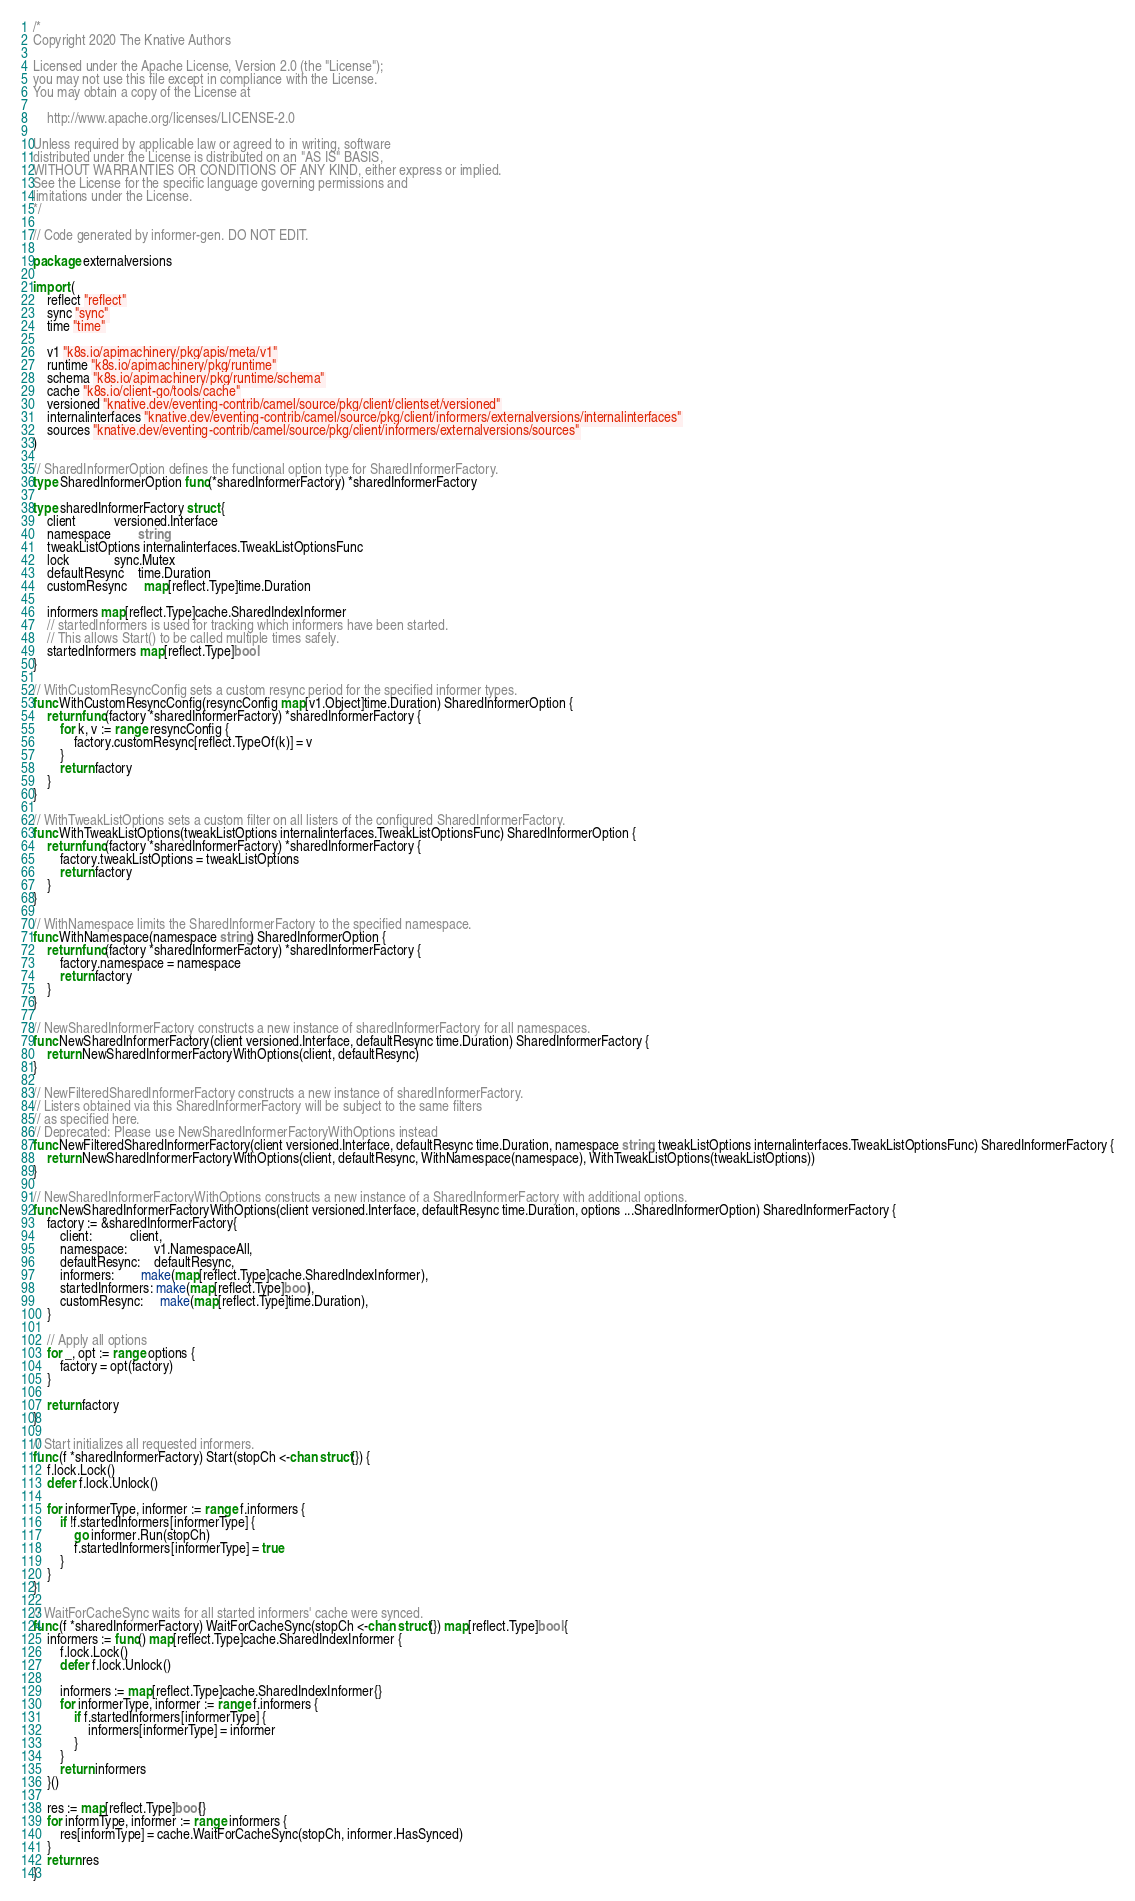Convert code to text. <code><loc_0><loc_0><loc_500><loc_500><_Go_>/*
Copyright 2020 The Knative Authors

Licensed under the Apache License, Version 2.0 (the "License");
you may not use this file except in compliance with the License.
You may obtain a copy of the License at

    http://www.apache.org/licenses/LICENSE-2.0

Unless required by applicable law or agreed to in writing, software
distributed under the License is distributed on an "AS IS" BASIS,
WITHOUT WARRANTIES OR CONDITIONS OF ANY KIND, either express or implied.
See the License for the specific language governing permissions and
limitations under the License.
*/

// Code generated by informer-gen. DO NOT EDIT.

package externalversions

import (
	reflect "reflect"
	sync "sync"
	time "time"

	v1 "k8s.io/apimachinery/pkg/apis/meta/v1"
	runtime "k8s.io/apimachinery/pkg/runtime"
	schema "k8s.io/apimachinery/pkg/runtime/schema"
	cache "k8s.io/client-go/tools/cache"
	versioned "knative.dev/eventing-contrib/camel/source/pkg/client/clientset/versioned"
	internalinterfaces "knative.dev/eventing-contrib/camel/source/pkg/client/informers/externalversions/internalinterfaces"
	sources "knative.dev/eventing-contrib/camel/source/pkg/client/informers/externalversions/sources"
)

// SharedInformerOption defines the functional option type for SharedInformerFactory.
type SharedInformerOption func(*sharedInformerFactory) *sharedInformerFactory

type sharedInformerFactory struct {
	client           versioned.Interface
	namespace        string
	tweakListOptions internalinterfaces.TweakListOptionsFunc
	lock             sync.Mutex
	defaultResync    time.Duration
	customResync     map[reflect.Type]time.Duration

	informers map[reflect.Type]cache.SharedIndexInformer
	// startedInformers is used for tracking which informers have been started.
	// This allows Start() to be called multiple times safely.
	startedInformers map[reflect.Type]bool
}

// WithCustomResyncConfig sets a custom resync period for the specified informer types.
func WithCustomResyncConfig(resyncConfig map[v1.Object]time.Duration) SharedInformerOption {
	return func(factory *sharedInformerFactory) *sharedInformerFactory {
		for k, v := range resyncConfig {
			factory.customResync[reflect.TypeOf(k)] = v
		}
		return factory
	}
}

// WithTweakListOptions sets a custom filter on all listers of the configured SharedInformerFactory.
func WithTweakListOptions(tweakListOptions internalinterfaces.TweakListOptionsFunc) SharedInformerOption {
	return func(factory *sharedInformerFactory) *sharedInformerFactory {
		factory.tweakListOptions = tweakListOptions
		return factory
	}
}

// WithNamespace limits the SharedInformerFactory to the specified namespace.
func WithNamespace(namespace string) SharedInformerOption {
	return func(factory *sharedInformerFactory) *sharedInformerFactory {
		factory.namespace = namespace
		return factory
	}
}

// NewSharedInformerFactory constructs a new instance of sharedInformerFactory for all namespaces.
func NewSharedInformerFactory(client versioned.Interface, defaultResync time.Duration) SharedInformerFactory {
	return NewSharedInformerFactoryWithOptions(client, defaultResync)
}

// NewFilteredSharedInformerFactory constructs a new instance of sharedInformerFactory.
// Listers obtained via this SharedInformerFactory will be subject to the same filters
// as specified here.
// Deprecated: Please use NewSharedInformerFactoryWithOptions instead
func NewFilteredSharedInformerFactory(client versioned.Interface, defaultResync time.Duration, namespace string, tweakListOptions internalinterfaces.TweakListOptionsFunc) SharedInformerFactory {
	return NewSharedInformerFactoryWithOptions(client, defaultResync, WithNamespace(namespace), WithTweakListOptions(tweakListOptions))
}

// NewSharedInformerFactoryWithOptions constructs a new instance of a SharedInformerFactory with additional options.
func NewSharedInformerFactoryWithOptions(client versioned.Interface, defaultResync time.Duration, options ...SharedInformerOption) SharedInformerFactory {
	factory := &sharedInformerFactory{
		client:           client,
		namespace:        v1.NamespaceAll,
		defaultResync:    defaultResync,
		informers:        make(map[reflect.Type]cache.SharedIndexInformer),
		startedInformers: make(map[reflect.Type]bool),
		customResync:     make(map[reflect.Type]time.Duration),
	}

	// Apply all options
	for _, opt := range options {
		factory = opt(factory)
	}

	return factory
}

// Start initializes all requested informers.
func (f *sharedInformerFactory) Start(stopCh <-chan struct{}) {
	f.lock.Lock()
	defer f.lock.Unlock()

	for informerType, informer := range f.informers {
		if !f.startedInformers[informerType] {
			go informer.Run(stopCh)
			f.startedInformers[informerType] = true
		}
	}
}

// WaitForCacheSync waits for all started informers' cache were synced.
func (f *sharedInformerFactory) WaitForCacheSync(stopCh <-chan struct{}) map[reflect.Type]bool {
	informers := func() map[reflect.Type]cache.SharedIndexInformer {
		f.lock.Lock()
		defer f.lock.Unlock()

		informers := map[reflect.Type]cache.SharedIndexInformer{}
		for informerType, informer := range f.informers {
			if f.startedInformers[informerType] {
				informers[informerType] = informer
			}
		}
		return informers
	}()

	res := map[reflect.Type]bool{}
	for informType, informer := range informers {
		res[informType] = cache.WaitForCacheSync(stopCh, informer.HasSynced)
	}
	return res
}
</code> 